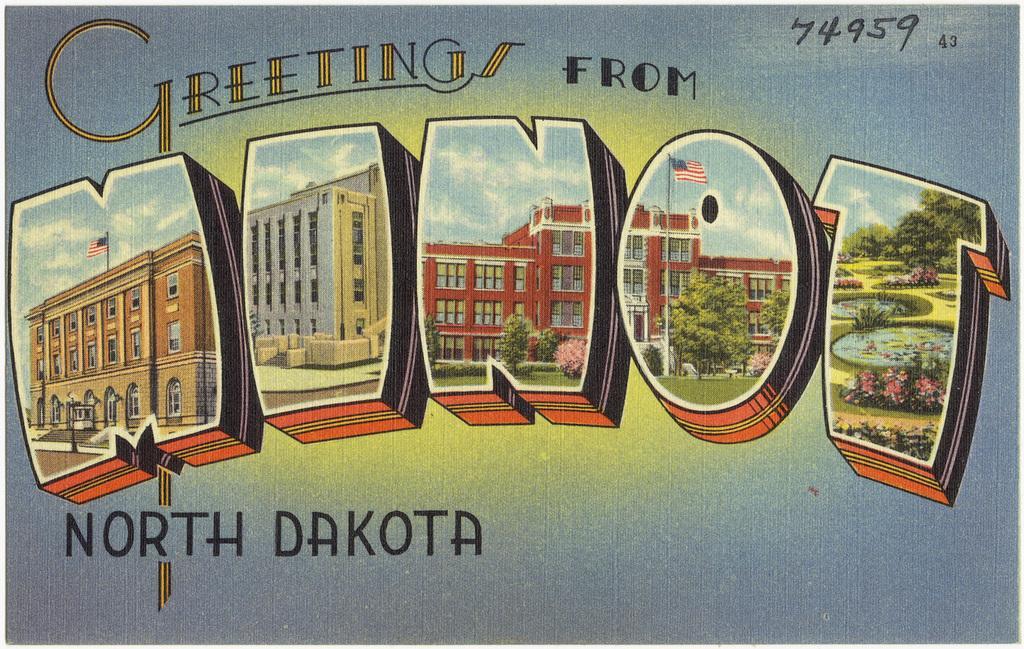Could you give a brief overview of what you see in this image? In this image, we can see a poster. On that poster, we can see some buildings with flags, we can also see some text written on the poster. In the background, we can see blue color and yellow color. 